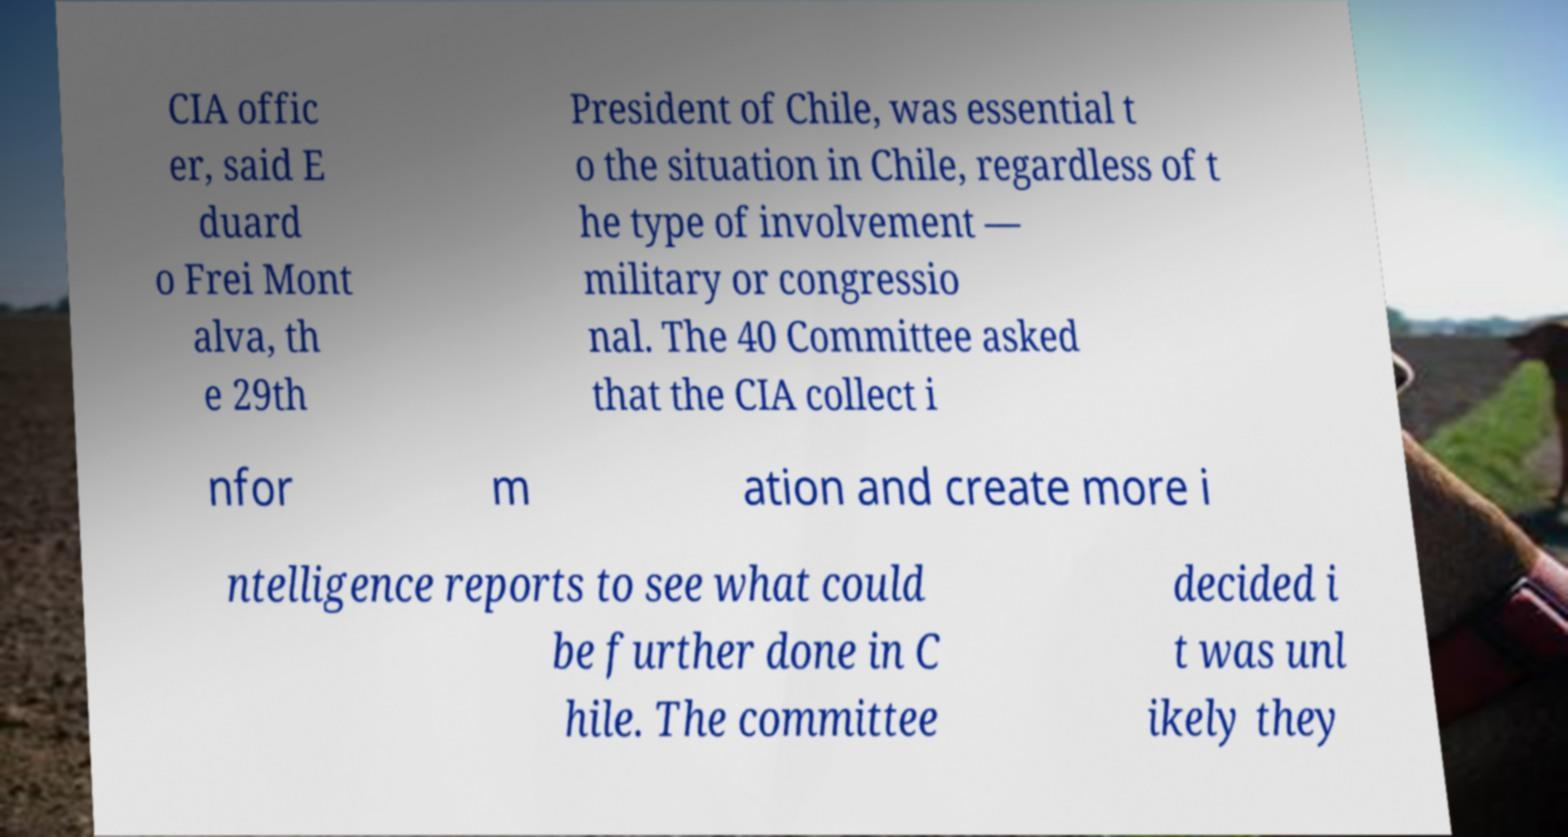Please read and relay the text visible in this image. What does it say? CIA offic er, said E duard o Frei Mont alva, th e 29th President of Chile, was essential t o the situation in Chile, regardless of t he type of involvement — military or congressio nal. The 40 Committee asked that the CIA collect i nfor m ation and create more i ntelligence reports to see what could be further done in C hile. The committee decided i t was unl ikely they 